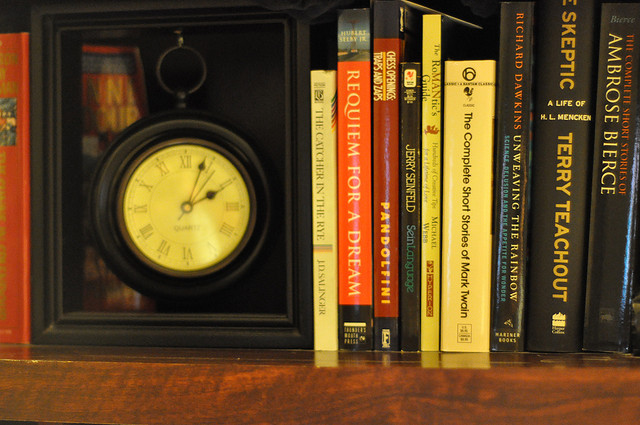Read and extract the text from this image. FOR Complete TERRY TEACHOUT RAINBOW Mark RYB CATCHER Ro.MANtic's ZAPS CHEESE REQUIEM A DREAM PANDOLFINI SEINFELD JERRY Twaln of Stories Short The THE UNWEAVING DAWKINS RICHARD COMPLETE STORIES OF BIERCE AMBROSE MENCHEN OF LIFE SKEPTIC 